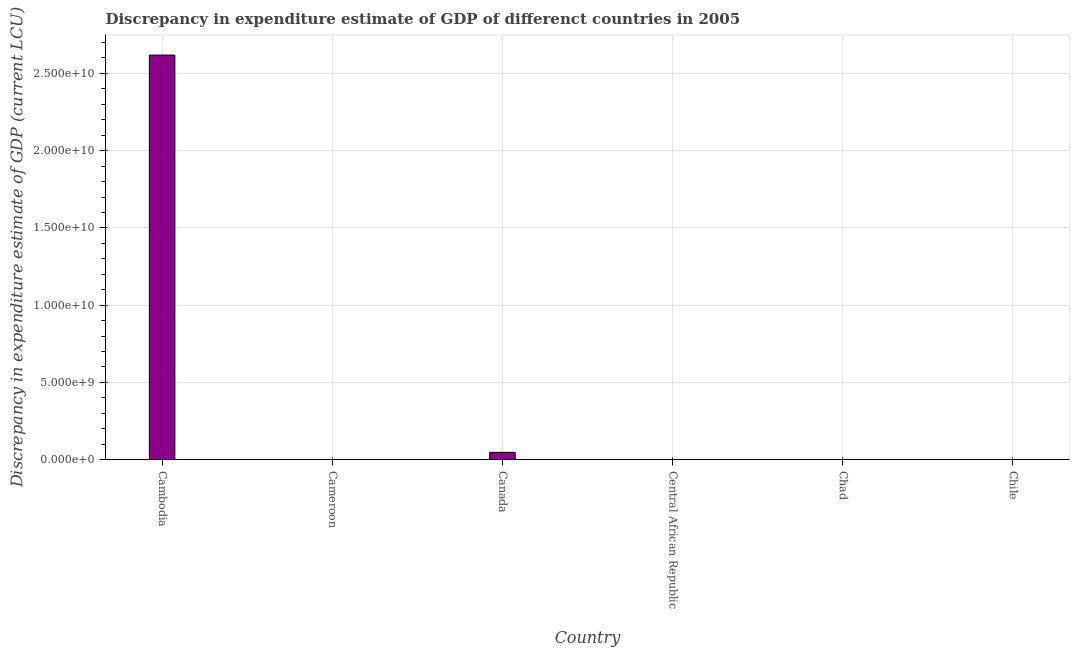What is the title of the graph?
Offer a very short reply. Discrepancy in expenditure estimate of GDP of differenct countries in 2005. What is the label or title of the Y-axis?
Offer a terse response. Discrepancy in expenditure estimate of GDP (current LCU). What is the discrepancy in expenditure estimate of gdp in Cambodia?
Offer a very short reply. 2.62e+1. Across all countries, what is the maximum discrepancy in expenditure estimate of gdp?
Make the answer very short. 2.62e+1. In which country was the discrepancy in expenditure estimate of gdp maximum?
Keep it short and to the point. Cambodia. What is the sum of the discrepancy in expenditure estimate of gdp?
Your answer should be compact. 2.67e+1. What is the difference between the discrepancy in expenditure estimate of gdp in Cameroon and Canada?
Provide a succinct answer. -4.74e+08. What is the average discrepancy in expenditure estimate of gdp per country?
Your answer should be very brief. 4.44e+09. What is the median discrepancy in expenditure estimate of gdp?
Provide a short and direct response. 100. In how many countries, is the discrepancy in expenditure estimate of gdp greater than 3000000000 LCU?
Offer a very short reply. 1. What is the ratio of the discrepancy in expenditure estimate of gdp in Cambodia to that in Chad?
Your answer should be compact. 2.62e+08. Is the discrepancy in expenditure estimate of gdp in Cambodia less than that in Canada?
Give a very brief answer. No. What is the difference between the highest and the second highest discrepancy in expenditure estimate of gdp?
Your answer should be very brief. 2.57e+1. Is the sum of the discrepancy in expenditure estimate of gdp in Cameroon and Chad greater than the maximum discrepancy in expenditure estimate of gdp across all countries?
Your answer should be compact. No. What is the difference between the highest and the lowest discrepancy in expenditure estimate of gdp?
Offer a very short reply. 2.62e+1. How many bars are there?
Make the answer very short. 4. Are all the bars in the graph horizontal?
Offer a very short reply. No. What is the difference between two consecutive major ticks on the Y-axis?
Ensure brevity in your answer.  5.00e+09. Are the values on the major ticks of Y-axis written in scientific E-notation?
Provide a succinct answer. Yes. What is the Discrepancy in expenditure estimate of GDP (current LCU) in Cambodia?
Your answer should be compact. 2.62e+1. What is the Discrepancy in expenditure estimate of GDP (current LCU) in Cameroon?
Ensure brevity in your answer.  100. What is the Discrepancy in expenditure estimate of GDP (current LCU) of Canada?
Your response must be concise. 4.74e+08. What is the Discrepancy in expenditure estimate of GDP (current LCU) of Chad?
Provide a short and direct response. 100. What is the difference between the Discrepancy in expenditure estimate of GDP (current LCU) in Cambodia and Cameroon?
Your response must be concise. 2.62e+1. What is the difference between the Discrepancy in expenditure estimate of GDP (current LCU) in Cambodia and Canada?
Your answer should be compact. 2.57e+1. What is the difference between the Discrepancy in expenditure estimate of GDP (current LCU) in Cambodia and Chad?
Provide a succinct answer. 2.62e+1. What is the difference between the Discrepancy in expenditure estimate of GDP (current LCU) in Cameroon and Canada?
Keep it short and to the point. -4.74e+08. What is the difference between the Discrepancy in expenditure estimate of GDP (current LCU) in Cameroon and Chad?
Ensure brevity in your answer.  0. What is the difference between the Discrepancy in expenditure estimate of GDP (current LCU) in Canada and Chad?
Keep it short and to the point. 4.74e+08. What is the ratio of the Discrepancy in expenditure estimate of GDP (current LCU) in Cambodia to that in Cameroon?
Ensure brevity in your answer.  2.62e+08. What is the ratio of the Discrepancy in expenditure estimate of GDP (current LCU) in Cambodia to that in Canada?
Provide a short and direct response. 55.24. What is the ratio of the Discrepancy in expenditure estimate of GDP (current LCU) in Cambodia to that in Chad?
Ensure brevity in your answer.  2.62e+08. What is the ratio of the Discrepancy in expenditure estimate of GDP (current LCU) in Cameroon to that in Canada?
Your response must be concise. 0. What is the ratio of the Discrepancy in expenditure estimate of GDP (current LCU) in Cameroon to that in Chad?
Your answer should be compact. 1. What is the ratio of the Discrepancy in expenditure estimate of GDP (current LCU) in Canada to that in Chad?
Your answer should be very brief. 4.74e+06. 